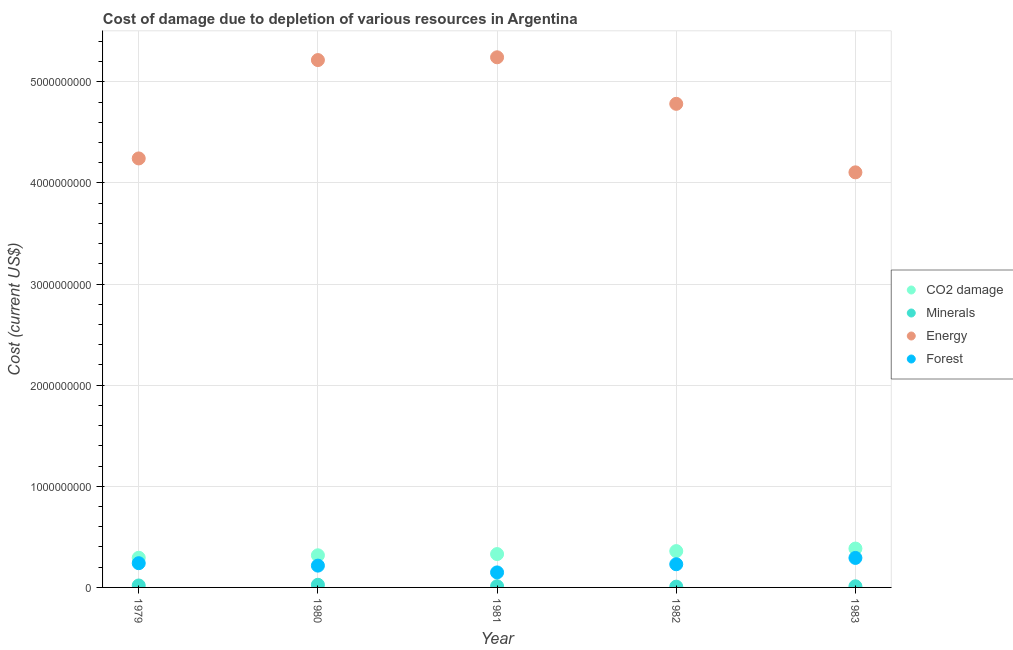What is the cost of damage due to depletion of energy in 1983?
Make the answer very short. 4.10e+09. Across all years, what is the maximum cost of damage due to depletion of energy?
Offer a very short reply. 5.24e+09. Across all years, what is the minimum cost of damage due to depletion of forests?
Make the answer very short. 1.48e+08. In which year was the cost of damage due to depletion of minerals maximum?
Offer a very short reply. 1980. What is the total cost of damage due to depletion of minerals in the graph?
Offer a terse response. 7.62e+07. What is the difference between the cost of damage due to depletion of minerals in 1980 and that in 1981?
Offer a terse response. 1.43e+07. What is the difference between the cost of damage due to depletion of energy in 1983 and the cost of damage due to depletion of minerals in 1980?
Your answer should be very brief. 4.08e+09. What is the average cost of damage due to depletion of coal per year?
Make the answer very short. 3.37e+08. In the year 1982, what is the difference between the cost of damage due to depletion of minerals and cost of damage due to depletion of forests?
Your answer should be very brief. -2.21e+08. In how many years, is the cost of damage due to depletion of minerals greater than 1800000000 US$?
Keep it short and to the point. 0. What is the ratio of the cost of damage due to depletion of forests in 1979 to that in 1982?
Keep it short and to the point. 1.05. Is the cost of damage due to depletion of minerals in 1979 less than that in 1981?
Your response must be concise. No. What is the difference between the highest and the second highest cost of damage due to depletion of energy?
Ensure brevity in your answer.  2.75e+07. What is the difference between the highest and the lowest cost of damage due to depletion of forests?
Make the answer very short. 1.43e+08. In how many years, is the cost of damage due to depletion of energy greater than the average cost of damage due to depletion of energy taken over all years?
Provide a succinct answer. 3. Is it the case that in every year, the sum of the cost of damage due to depletion of coal and cost of damage due to depletion of minerals is greater than the cost of damage due to depletion of energy?
Provide a succinct answer. No. Is the cost of damage due to depletion of forests strictly greater than the cost of damage due to depletion of energy over the years?
Your answer should be very brief. No. Is the cost of damage due to depletion of energy strictly less than the cost of damage due to depletion of minerals over the years?
Provide a succinct answer. No. How many dotlines are there?
Give a very brief answer. 4. Are the values on the major ticks of Y-axis written in scientific E-notation?
Offer a very short reply. No. Where does the legend appear in the graph?
Your response must be concise. Center right. How many legend labels are there?
Provide a succinct answer. 4. What is the title of the graph?
Your response must be concise. Cost of damage due to depletion of various resources in Argentina . Does "Secondary schools" appear as one of the legend labels in the graph?
Your response must be concise. No. What is the label or title of the X-axis?
Your answer should be very brief. Year. What is the label or title of the Y-axis?
Provide a short and direct response. Cost (current US$). What is the Cost (current US$) of CO2 damage in 1979?
Offer a very short reply. 2.93e+08. What is the Cost (current US$) in Minerals in 1979?
Offer a terse response. 1.93e+07. What is the Cost (current US$) of Energy in 1979?
Keep it short and to the point. 4.24e+09. What is the Cost (current US$) of Forest in 1979?
Offer a terse response. 2.40e+08. What is the Cost (current US$) of CO2 damage in 1980?
Offer a very short reply. 3.18e+08. What is the Cost (current US$) in Minerals in 1980?
Offer a very short reply. 2.60e+07. What is the Cost (current US$) of Energy in 1980?
Your response must be concise. 5.21e+09. What is the Cost (current US$) of Forest in 1980?
Offer a very short reply. 2.16e+08. What is the Cost (current US$) in CO2 damage in 1981?
Your response must be concise. 3.30e+08. What is the Cost (current US$) in Minerals in 1981?
Your answer should be compact. 1.18e+07. What is the Cost (current US$) of Energy in 1981?
Offer a very short reply. 5.24e+09. What is the Cost (current US$) of Forest in 1981?
Provide a short and direct response. 1.48e+08. What is the Cost (current US$) of CO2 damage in 1982?
Provide a succinct answer. 3.59e+08. What is the Cost (current US$) in Minerals in 1982?
Offer a very short reply. 7.86e+06. What is the Cost (current US$) of Energy in 1982?
Offer a very short reply. 4.78e+09. What is the Cost (current US$) in Forest in 1982?
Offer a very short reply. 2.29e+08. What is the Cost (current US$) in CO2 damage in 1983?
Provide a short and direct response. 3.84e+08. What is the Cost (current US$) in Minerals in 1983?
Offer a very short reply. 1.12e+07. What is the Cost (current US$) of Energy in 1983?
Your answer should be very brief. 4.10e+09. What is the Cost (current US$) of Forest in 1983?
Keep it short and to the point. 2.92e+08. Across all years, what is the maximum Cost (current US$) of CO2 damage?
Provide a short and direct response. 3.84e+08. Across all years, what is the maximum Cost (current US$) in Minerals?
Offer a very short reply. 2.60e+07. Across all years, what is the maximum Cost (current US$) in Energy?
Ensure brevity in your answer.  5.24e+09. Across all years, what is the maximum Cost (current US$) of Forest?
Provide a succinct answer. 2.92e+08. Across all years, what is the minimum Cost (current US$) of CO2 damage?
Provide a succinct answer. 2.93e+08. Across all years, what is the minimum Cost (current US$) of Minerals?
Your response must be concise. 7.86e+06. Across all years, what is the minimum Cost (current US$) of Energy?
Give a very brief answer. 4.10e+09. Across all years, what is the minimum Cost (current US$) in Forest?
Make the answer very short. 1.48e+08. What is the total Cost (current US$) in CO2 damage in the graph?
Provide a short and direct response. 1.68e+09. What is the total Cost (current US$) of Minerals in the graph?
Your answer should be very brief. 7.62e+07. What is the total Cost (current US$) in Energy in the graph?
Ensure brevity in your answer.  2.36e+1. What is the total Cost (current US$) of Forest in the graph?
Your response must be concise. 1.12e+09. What is the difference between the Cost (current US$) of CO2 damage in 1979 and that in 1980?
Keep it short and to the point. -2.45e+07. What is the difference between the Cost (current US$) in Minerals in 1979 and that in 1980?
Keep it short and to the point. -6.76e+06. What is the difference between the Cost (current US$) of Energy in 1979 and that in 1980?
Ensure brevity in your answer.  -9.73e+08. What is the difference between the Cost (current US$) in Forest in 1979 and that in 1980?
Give a very brief answer. 2.41e+07. What is the difference between the Cost (current US$) in CO2 damage in 1979 and that in 1981?
Keep it short and to the point. -3.66e+07. What is the difference between the Cost (current US$) of Minerals in 1979 and that in 1981?
Provide a succinct answer. 7.51e+06. What is the difference between the Cost (current US$) in Energy in 1979 and that in 1981?
Make the answer very short. -1.00e+09. What is the difference between the Cost (current US$) in Forest in 1979 and that in 1981?
Give a very brief answer. 9.11e+07. What is the difference between the Cost (current US$) in CO2 damage in 1979 and that in 1982?
Your answer should be very brief. -6.59e+07. What is the difference between the Cost (current US$) of Minerals in 1979 and that in 1982?
Your answer should be compact. 1.14e+07. What is the difference between the Cost (current US$) in Energy in 1979 and that in 1982?
Your response must be concise. -5.40e+08. What is the difference between the Cost (current US$) of Forest in 1979 and that in 1982?
Ensure brevity in your answer.  1.04e+07. What is the difference between the Cost (current US$) of CO2 damage in 1979 and that in 1983?
Give a very brief answer. -9.11e+07. What is the difference between the Cost (current US$) of Minerals in 1979 and that in 1983?
Keep it short and to the point. 8.03e+06. What is the difference between the Cost (current US$) of Energy in 1979 and that in 1983?
Give a very brief answer. 1.37e+08. What is the difference between the Cost (current US$) in Forest in 1979 and that in 1983?
Your answer should be compact. -5.21e+07. What is the difference between the Cost (current US$) in CO2 damage in 1980 and that in 1981?
Keep it short and to the point. -1.21e+07. What is the difference between the Cost (current US$) of Minerals in 1980 and that in 1981?
Make the answer very short. 1.43e+07. What is the difference between the Cost (current US$) of Energy in 1980 and that in 1981?
Give a very brief answer. -2.75e+07. What is the difference between the Cost (current US$) of Forest in 1980 and that in 1981?
Your answer should be very brief. 6.71e+07. What is the difference between the Cost (current US$) of CO2 damage in 1980 and that in 1982?
Provide a short and direct response. -4.15e+07. What is the difference between the Cost (current US$) of Minerals in 1980 and that in 1982?
Your answer should be very brief. 1.82e+07. What is the difference between the Cost (current US$) in Energy in 1980 and that in 1982?
Your response must be concise. 4.33e+08. What is the difference between the Cost (current US$) in Forest in 1980 and that in 1982?
Ensure brevity in your answer.  -1.37e+07. What is the difference between the Cost (current US$) of CO2 damage in 1980 and that in 1983?
Keep it short and to the point. -6.66e+07. What is the difference between the Cost (current US$) in Minerals in 1980 and that in 1983?
Your response must be concise. 1.48e+07. What is the difference between the Cost (current US$) in Energy in 1980 and that in 1983?
Provide a succinct answer. 1.11e+09. What is the difference between the Cost (current US$) in Forest in 1980 and that in 1983?
Keep it short and to the point. -7.62e+07. What is the difference between the Cost (current US$) of CO2 damage in 1981 and that in 1982?
Give a very brief answer. -2.94e+07. What is the difference between the Cost (current US$) in Minerals in 1981 and that in 1982?
Your answer should be very brief. 3.91e+06. What is the difference between the Cost (current US$) of Energy in 1981 and that in 1982?
Provide a succinct answer. 4.60e+08. What is the difference between the Cost (current US$) in Forest in 1981 and that in 1982?
Offer a terse response. -8.08e+07. What is the difference between the Cost (current US$) in CO2 damage in 1981 and that in 1983?
Provide a short and direct response. -5.45e+07. What is the difference between the Cost (current US$) of Minerals in 1981 and that in 1983?
Make the answer very short. 5.26e+05. What is the difference between the Cost (current US$) of Energy in 1981 and that in 1983?
Ensure brevity in your answer.  1.14e+09. What is the difference between the Cost (current US$) of Forest in 1981 and that in 1983?
Your answer should be very brief. -1.43e+08. What is the difference between the Cost (current US$) of CO2 damage in 1982 and that in 1983?
Your response must be concise. -2.51e+07. What is the difference between the Cost (current US$) in Minerals in 1982 and that in 1983?
Keep it short and to the point. -3.38e+06. What is the difference between the Cost (current US$) of Energy in 1982 and that in 1983?
Offer a very short reply. 6.77e+08. What is the difference between the Cost (current US$) in Forest in 1982 and that in 1983?
Your response must be concise. -6.25e+07. What is the difference between the Cost (current US$) of CO2 damage in 1979 and the Cost (current US$) of Minerals in 1980?
Make the answer very short. 2.67e+08. What is the difference between the Cost (current US$) in CO2 damage in 1979 and the Cost (current US$) in Energy in 1980?
Offer a very short reply. -4.92e+09. What is the difference between the Cost (current US$) in CO2 damage in 1979 and the Cost (current US$) in Forest in 1980?
Offer a very short reply. 7.77e+07. What is the difference between the Cost (current US$) of Minerals in 1979 and the Cost (current US$) of Energy in 1980?
Your answer should be compact. -5.20e+09. What is the difference between the Cost (current US$) in Minerals in 1979 and the Cost (current US$) in Forest in 1980?
Your answer should be compact. -1.96e+08. What is the difference between the Cost (current US$) in Energy in 1979 and the Cost (current US$) in Forest in 1980?
Ensure brevity in your answer.  4.03e+09. What is the difference between the Cost (current US$) of CO2 damage in 1979 and the Cost (current US$) of Minerals in 1981?
Offer a terse response. 2.81e+08. What is the difference between the Cost (current US$) of CO2 damage in 1979 and the Cost (current US$) of Energy in 1981?
Provide a succinct answer. -4.95e+09. What is the difference between the Cost (current US$) in CO2 damage in 1979 and the Cost (current US$) in Forest in 1981?
Offer a very short reply. 1.45e+08. What is the difference between the Cost (current US$) of Minerals in 1979 and the Cost (current US$) of Energy in 1981?
Provide a succinct answer. -5.22e+09. What is the difference between the Cost (current US$) of Minerals in 1979 and the Cost (current US$) of Forest in 1981?
Give a very brief answer. -1.29e+08. What is the difference between the Cost (current US$) in Energy in 1979 and the Cost (current US$) in Forest in 1981?
Your answer should be compact. 4.09e+09. What is the difference between the Cost (current US$) of CO2 damage in 1979 and the Cost (current US$) of Minerals in 1982?
Provide a short and direct response. 2.85e+08. What is the difference between the Cost (current US$) in CO2 damage in 1979 and the Cost (current US$) in Energy in 1982?
Offer a very short reply. -4.49e+09. What is the difference between the Cost (current US$) in CO2 damage in 1979 and the Cost (current US$) in Forest in 1982?
Ensure brevity in your answer.  6.41e+07. What is the difference between the Cost (current US$) of Minerals in 1979 and the Cost (current US$) of Energy in 1982?
Your answer should be compact. -4.76e+09. What is the difference between the Cost (current US$) in Minerals in 1979 and the Cost (current US$) in Forest in 1982?
Ensure brevity in your answer.  -2.10e+08. What is the difference between the Cost (current US$) of Energy in 1979 and the Cost (current US$) of Forest in 1982?
Offer a terse response. 4.01e+09. What is the difference between the Cost (current US$) in CO2 damage in 1979 and the Cost (current US$) in Minerals in 1983?
Make the answer very short. 2.82e+08. What is the difference between the Cost (current US$) of CO2 damage in 1979 and the Cost (current US$) of Energy in 1983?
Provide a short and direct response. -3.81e+09. What is the difference between the Cost (current US$) in CO2 damage in 1979 and the Cost (current US$) in Forest in 1983?
Offer a terse response. 1.58e+06. What is the difference between the Cost (current US$) in Minerals in 1979 and the Cost (current US$) in Energy in 1983?
Give a very brief answer. -4.09e+09. What is the difference between the Cost (current US$) of Minerals in 1979 and the Cost (current US$) of Forest in 1983?
Make the answer very short. -2.72e+08. What is the difference between the Cost (current US$) in Energy in 1979 and the Cost (current US$) in Forest in 1983?
Offer a terse response. 3.95e+09. What is the difference between the Cost (current US$) of CO2 damage in 1980 and the Cost (current US$) of Minerals in 1981?
Keep it short and to the point. 3.06e+08. What is the difference between the Cost (current US$) in CO2 damage in 1980 and the Cost (current US$) in Energy in 1981?
Ensure brevity in your answer.  -4.92e+09. What is the difference between the Cost (current US$) in CO2 damage in 1980 and the Cost (current US$) in Forest in 1981?
Offer a very short reply. 1.69e+08. What is the difference between the Cost (current US$) of Minerals in 1980 and the Cost (current US$) of Energy in 1981?
Offer a terse response. -5.22e+09. What is the difference between the Cost (current US$) of Minerals in 1980 and the Cost (current US$) of Forest in 1981?
Your response must be concise. -1.22e+08. What is the difference between the Cost (current US$) of Energy in 1980 and the Cost (current US$) of Forest in 1981?
Provide a short and direct response. 5.07e+09. What is the difference between the Cost (current US$) of CO2 damage in 1980 and the Cost (current US$) of Minerals in 1982?
Offer a very short reply. 3.10e+08. What is the difference between the Cost (current US$) of CO2 damage in 1980 and the Cost (current US$) of Energy in 1982?
Offer a very short reply. -4.46e+09. What is the difference between the Cost (current US$) of CO2 damage in 1980 and the Cost (current US$) of Forest in 1982?
Your response must be concise. 8.85e+07. What is the difference between the Cost (current US$) of Minerals in 1980 and the Cost (current US$) of Energy in 1982?
Give a very brief answer. -4.76e+09. What is the difference between the Cost (current US$) in Minerals in 1980 and the Cost (current US$) in Forest in 1982?
Offer a terse response. -2.03e+08. What is the difference between the Cost (current US$) of Energy in 1980 and the Cost (current US$) of Forest in 1982?
Your response must be concise. 4.99e+09. What is the difference between the Cost (current US$) of CO2 damage in 1980 and the Cost (current US$) of Minerals in 1983?
Your answer should be very brief. 3.06e+08. What is the difference between the Cost (current US$) in CO2 damage in 1980 and the Cost (current US$) in Energy in 1983?
Keep it short and to the point. -3.79e+09. What is the difference between the Cost (current US$) of CO2 damage in 1980 and the Cost (current US$) of Forest in 1983?
Your answer should be very brief. 2.60e+07. What is the difference between the Cost (current US$) in Minerals in 1980 and the Cost (current US$) in Energy in 1983?
Your answer should be very brief. -4.08e+09. What is the difference between the Cost (current US$) in Minerals in 1980 and the Cost (current US$) in Forest in 1983?
Provide a succinct answer. -2.66e+08. What is the difference between the Cost (current US$) in Energy in 1980 and the Cost (current US$) in Forest in 1983?
Ensure brevity in your answer.  4.92e+09. What is the difference between the Cost (current US$) in CO2 damage in 1981 and the Cost (current US$) in Minerals in 1982?
Provide a short and direct response. 3.22e+08. What is the difference between the Cost (current US$) in CO2 damage in 1981 and the Cost (current US$) in Energy in 1982?
Provide a short and direct response. -4.45e+09. What is the difference between the Cost (current US$) of CO2 damage in 1981 and the Cost (current US$) of Forest in 1982?
Your response must be concise. 1.01e+08. What is the difference between the Cost (current US$) in Minerals in 1981 and the Cost (current US$) in Energy in 1982?
Your answer should be compact. -4.77e+09. What is the difference between the Cost (current US$) of Minerals in 1981 and the Cost (current US$) of Forest in 1982?
Provide a succinct answer. -2.17e+08. What is the difference between the Cost (current US$) in Energy in 1981 and the Cost (current US$) in Forest in 1982?
Offer a terse response. 5.01e+09. What is the difference between the Cost (current US$) in CO2 damage in 1981 and the Cost (current US$) in Minerals in 1983?
Ensure brevity in your answer.  3.19e+08. What is the difference between the Cost (current US$) in CO2 damage in 1981 and the Cost (current US$) in Energy in 1983?
Your answer should be compact. -3.77e+09. What is the difference between the Cost (current US$) of CO2 damage in 1981 and the Cost (current US$) of Forest in 1983?
Your answer should be compact. 3.81e+07. What is the difference between the Cost (current US$) of Minerals in 1981 and the Cost (current US$) of Energy in 1983?
Offer a very short reply. -4.09e+09. What is the difference between the Cost (current US$) of Minerals in 1981 and the Cost (current US$) of Forest in 1983?
Ensure brevity in your answer.  -2.80e+08. What is the difference between the Cost (current US$) of Energy in 1981 and the Cost (current US$) of Forest in 1983?
Your response must be concise. 4.95e+09. What is the difference between the Cost (current US$) in CO2 damage in 1982 and the Cost (current US$) in Minerals in 1983?
Your response must be concise. 3.48e+08. What is the difference between the Cost (current US$) in CO2 damage in 1982 and the Cost (current US$) in Energy in 1983?
Provide a short and direct response. -3.75e+09. What is the difference between the Cost (current US$) in CO2 damage in 1982 and the Cost (current US$) in Forest in 1983?
Your answer should be compact. 6.75e+07. What is the difference between the Cost (current US$) of Minerals in 1982 and the Cost (current US$) of Energy in 1983?
Provide a short and direct response. -4.10e+09. What is the difference between the Cost (current US$) in Minerals in 1982 and the Cost (current US$) in Forest in 1983?
Give a very brief answer. -2.84e+08. What is the difference between the Cost (current US$) in Energy in 1982 and the Cost (current US$) in Forest in 1983?
Provide a succinct answer. 4.49e+09. What is the average Cost (current US$) of CO2 damage per year?
Keep it short and to the point. 3.37e+08. What is the average Cost (current US$) of Minerals per year?
Offer a terse response. 1.52e+07. What is the average Cost (current US$) in Energy per year?
Provide a succinct answer. 4.72e+09. What is the average Cost (current US$) in Forest per year?
Your answer should be compact. 2.25e+08. In the year 1979, what is the difference between the Cost (current US$) of CO2 damage and Cost (current US$) of Minerals?
Provide a short and direct response. 2.74e+08. In the year 1979, what is the difference between the Cost (current US$) of CO2 damage and Cost (current US$) of Energy?
Make the answer very short. -3.95e+09. In the year 1979, what is the difference between the Cost (current US$) in CO2 damage and Cost (current US$) in Forest?
Give a very brief answer. 5.37e+07. In the year 1979, what is the difference between the Cost (current US$) of Minerals and Cost (current US$) of Energy?
Ensure brevity in your answer.  -4.22e+09. In the year 1979, what is the difference between the Cost (current US$) in Minerals and Cost (current US$) in Forest?
Your answer should be compact. -2.20e+08. In the year 1979, what is the difference between the Cost (current US$) of Energy and Cost (current US$) of Forest?
Provide a succinct answer. 4.00e+09. In the year 1980, what is the difference between the Cost (current US$) of CO2 damage and Cost (current US$) of Minerals?
Your answer should be compact. 2.92e+08. In the year 1980, what is the difference between the Cost (current US$) of CO2 damage and Cost (current US$) of Energy?
Provide a succinct answer. -4.90e+09. In the year 1980, what is the difference between the Cost (current US$) in CO2 damage and Cost (current US$) in Forest?
Make the answer very short. 1.02e+08. In the year 1980, what is the difference between the Cost (current US$) in Minerals and Cost (current US$) in Energy?
Your response must be concise. -5.19e+09. In the year 1980, what is the difference between the Cost (current US$) of Minerals and Cost (current US$) of Forest?
Keep it short and to the point. -1.89e+08. In the year 1980, what is the difference between the Cost (current US$) of Energy and Cost (current US$) of Forest?
Your answer should be very brief. 5.00e+09. In the year 1981, what is the difference between the Cost (current US$) of CO2 damage and Cost (current US$) of Minerals?
Your answer should be very brief. 3.18e+08. In the year 1981, what is the difference between the Cost (current US$) of CO2 damage and Cost (current US$) of Energy?
Make the answer very short. -4.91e+09. In the year 1981, what is the difference between the Cost (current US$) of CO2 damage and Cost (current US$) of Forest?
Your response must be concise. 1.81e+08. In the year 1981, what is the difference between the Cost (current US$) of Minerals and Cost (current US$) of Energy?
Provide a succinct answer. -5.23e+09. In the year 1981, what is the difference between the Cost (current US$) of Minerals and Cost (current US$) of Forest?
Your response must be concise. -1.37e+08. In the year 1981, what is the difference between the Cost (current US$) of Energy and Cost (current US$) of Forest?
Offer a terse response. 5.09e+09. In the year 1982, what is the difference between the Cost (current US$) of CO2 damage and Cost (current US$) of Minerals?
Provide a short and direct response. 3.51e+08. In the year 1982, what is the difference between the Cost (current US$) in CO2 damage and Cost (current US$) in Energy?
Give a very brief answer. -4.42e+09. In the year 1982, what is the difference between the Cost (current US$) in CO2 damage and Cost (current US$) in Forest?
Offer a terse response. 1.30e+08. In the year 1982, what is the difference between the Cost (current US$) in Minerals and Cost (current US$) in Energy?
Your answer should be compact. -4.77e+09. In the year 1982, what is the difference between the Cost (current US$) of Minerals and Cost (current US$) of Forest?
Offer a terse response. -2.21e+08. In the year 1982, what is the difference between the Cost (current US$) in Energy and Cost (current US$) in Forest?
Your answer should be very brief. 4.55e+09. In the year 1983, what is the difference between the Cost (current US$) in CO2 damage and Cost (current US$) in Minerals?
Make the answer very short. 3.73e+08. In the year 1983, what is the difference between the Cost (current US$) in CO2 damage and Cost (current US$) in Energy?
Your answer should be very brief. -3.72e+09. In the year 1983, what is the difference between the Cost (current US$) in CO2 damage and Cost (current US$) in Forest?
Keep it short and to the point. 9.26e+07. In the year 1983, what is the difference between the Cost (current US$) of Minerals and Cost (current US$) of Energy?
Your response must be concise. -4.09e+09. In the year 1983, what is the difference between the Cost (current US$) in Minerals and Cost (current US$) in Forest?
Ensure brevity in your answer.  -2.80e+08. In the year 1983, what is the difference between the Cost (current US$) in Energy and Cost (current US$) in Forest?
Ensure brevity in your answer.  3.81e+09. What is the ratio of the Cost (current US$) of CO2 damage in 1979 to that in 1980?
Make the answer very short. 0.92. What is the ratio of the Cost (current US$) of Minerals in 1979 to that in 1980?
Offer a terse response. 0.74. What is the ratio of the Cost (current US$) of Energy in 1979 to that in 1980?
Make the answer very short. 0.81. What is the ratio of the Cost (current US$) in Forest in 1979 to that in 1980?
Make the answer very short. 1.11. What is the ratio of the Cost (current US$) of CO2 damage in 1979 to that in 1981?
Make the answer very short. 0.89. What is the ratio of the Cost (current US$) in Minerals in 1979 to that in 1981?
Provide a succinct answer. 1.64. What is the ratio of the Cost (current US$) in Energy in 1979 to that in 1981?
Give a very brief answer. 0.81. What is the ratio of the Cost (current US$) of Forest in 1979 to that in 1981?
Provide a short and direct response. 1.61. What is the ratio of the Cost (current US$) in CO2 damage in 1979 to that in 1982?
Make the answer very short. 0.82. What is the ratio of the Cost (current US$) in Minerals in 1979 to that in 1982?
Provide a succinct answer. 2.45. What is the ratio of the Cost (current US$) of Energy in 1979 to that in 1982?
Give a very brief answer. 0.89. What is the ratio of the Cost (current US$) in Forest in 1979 to that in 1982?
Offer a very short reply. 1.05. What is the ratio of the Cost (current US$) of CO2 damage in 1979 to that in 1983?
Ensure brevity in your answer.  0.76. What is the ratio of the Cost (current US$) of Minerals in 1979 to that in 1983?
Make the answer very short. 1.71. What is the ratio of the Cost (current US$) in Energy in 1979 to that in 1983?
Your answer should be compact. 1.03. What is the ratio of the Cost (current US$) in Forest in 1979 to that in 1983?
Your answer should be very brief. 0.82. What is the ratio of the Cost (current US$) in CO2 damage in 1980 to that in 1981?
Your response must be concise. 0.96. What is the ratio of the Cost (current US$) of Minerals in 1980 to that in 1981?
Offer a very short reply. 2.21. What is the ratio of the Cost (current US$) of Energy in 1980 to that in 1981?
Offer a very short reply. 0.99. What is the ratio of the Cost (current US$) in Forest in 1980 to that in 1981?
Offer a very short reply. 1.45. What is the ratio of the Cost (current US$) in CO2 damage in 1980 to that in 1982?
Offer a terse response. 0.88. What is the ratio of the Cost (current US$) of Minerals in 1980 to that in 1982?
Provide a short and direct response. 3.31. What is the ratio of the Cost (current US$) in Energy in 1980 to that in 1982?
Give a very brief answer. 1.09. What is the ratio of the Cost (current US$) of Forest in 1980 to that in 1982?
Make the answer very short. 0.94. What is the ratio of the Cost (current US$) in CO2 damage in 1980 to that in 1983?
Offer a very short reply. 0.83. What is the ratio of the Cost (current US$) in Minerals in 1980 to that in 1983?
Keep it short and to the point. 2.32. What is the ratio of the Cost (current US$) in Energy in 1980 to that in 1983?
Offer a very short reply. 1.27. What is the ratio of the Cost (current US$) in Forest in 1980 to that in 1983?
Provide a succinct answer. 0.74. What is the ratio of the Cost (current US$) of CO2 damage in 1981 to that in 1982?
Keep it short and to the point. 0.92. What is the ratio of the Cost (current US$) of Minerals in 1981 to that in 1982?
Give a very brief answer. 1.5. What is the ratio of the Cost (current US$) of Energy in 1981 to that in 1982?
Provide a short and direct response. 1.1. What is the ratio of the Cost (current US$) of Forest in 1981 to that in 1982?
Provide a short and direct response. 0.65. What is the ratio of the Cost (current US$) in CO2 damage in 1981 to that in 1983?
Offer a terse response. 0.86. What is the ratio of the Cost (current US$) of Minerals in 1981 to that in 1983?
Your response must be concise. 1.05. What is the ratio of the Cost (current US$) of Energy in 1981 to that in 1983?
Ensure brevity in your answer.  1.28. What is the ratio of the Cost (current US$) in Forest in 1981 to that in 1983?
Offer a very short reply. 0.51. What is the ratio of the Cost (current US$) of CO2 damage in 1982 to that in 1983?
Your answer should be very brief. 0.93. What is the ratio of the Cost (current US$) of Minerals in 1982 to that in 1983?
Provide a succinct answer. 0.7. What is the ratio of the Cost (current US$) of Energy in 1982 to that in 1983?
Keep it short and to the point. 1.17. What is the ratio of the Cost (current US$) of Forest in 1982 to that in 1983?
Your answer should be very brief. 0.79. What is the difference between the highest and the second highest Cost (current US$) of CO2 damage?
Provide a succinct answer. 2.51e+07. What is the difference between the highest and the second highest Cost (current US$) in Minerals?
Offer a very short reply. 6.76e+06. What is the difference between the highest and the second highest Cost (current US$) of Energy?
Provide a short and direct response. 2.75e+07. What is the difference between the highest and the second highest Cost (current US$) of Forest?
Your answer should be very brief. 5.21e+07. What is the difference between the highest and the lowest Cost (current US$) in CO2 damage?
Give a very brief answer. 9.11e+07. What is the difference between the highest and the lowest Cost (current US$) of Minerals?
Keep it short and to the point. 1.82e+07. What is the difference between the highest and the lowest Cost (current US$) in Energy?
Provide a short and direct response. 1.14e+09. What is the difference between the highest and the lowest Cost (current US$) of Forest?
Your answer should be compact. 1.43e+08. 